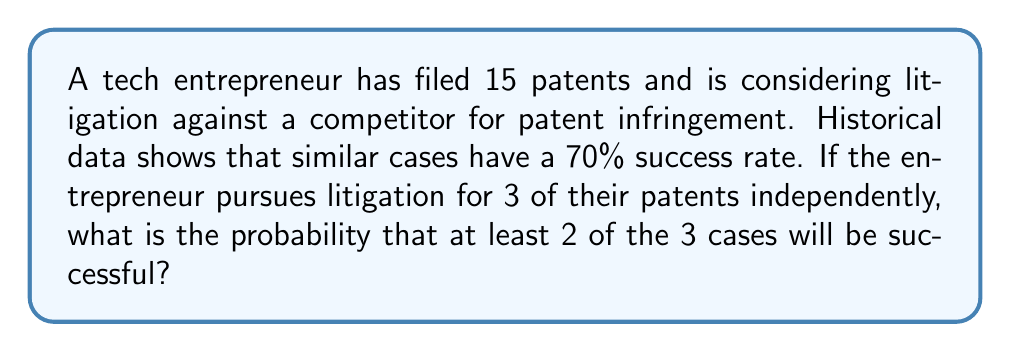Provide a solution to this math problem. Let's approach this step-by-step:

1) This scenario follows a binomial probability distribution, where:
   - n (number of trials) = 3
   - p (probability of success for each trial) = 0.70
   - We want at least 2 successes

2) The probability of at least 2 successes is the sum of the probabilities of exactly 2 successes and exactly 3 successes.

3) Using the binomial probability formula:
   $P(X = k) = \binom{n}{k} p^k (1-p)^{n-k}$

4) For exactly 2 successes:
   $P(X = 2) = \binom{3}{2} (0.70)^2 (0.30)^1$
   $= 3 \cdot 0.49 \cdot 0.30 = 0.441$

5) For exactly 3 successes:
   $P(X = 3) = \binom{3}{3} (0.70)^3 (0.30)^0$
   $= 1 \cdot 0.343 \cdot 1 = 0.343$

6) The probability of at least 2 successes is the sum of these:
   $P(X \geq 2) = P(X = 2) + P(X = 3)$
   $= 0.441 + 0.343 = 0.784$

Therefore, the probability of winning at least 2 out of 3 patent litigation cases is 0.784 or 78.4%.
Answer: 0.784 